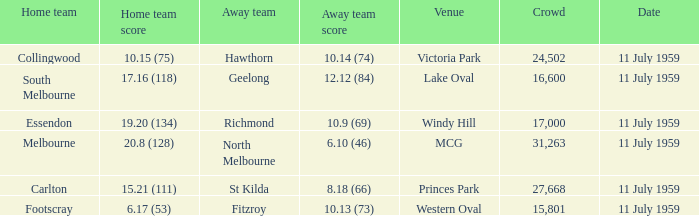How many points does footscray score as the home side? 6.17 (53). 